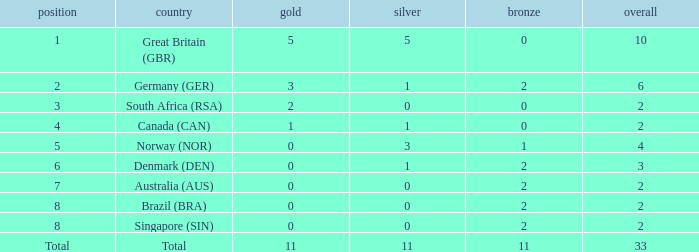What is the least total when the nation is canada (can) and bronze is less than 0? None. 